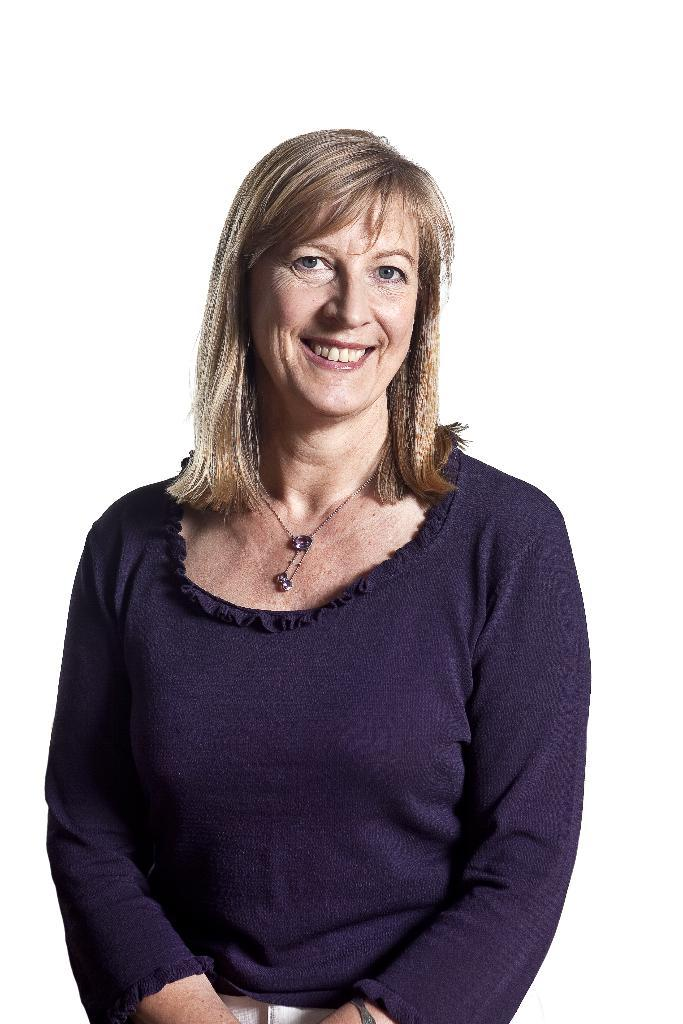Who is the main subject in the image? There is a lady in the image. What color is the background of the image? The background of the image is white in color. What type of observation is the lady making during the meeting in the image? There is no meeting or observation depicted in the image; it only features a lady with a white background. 